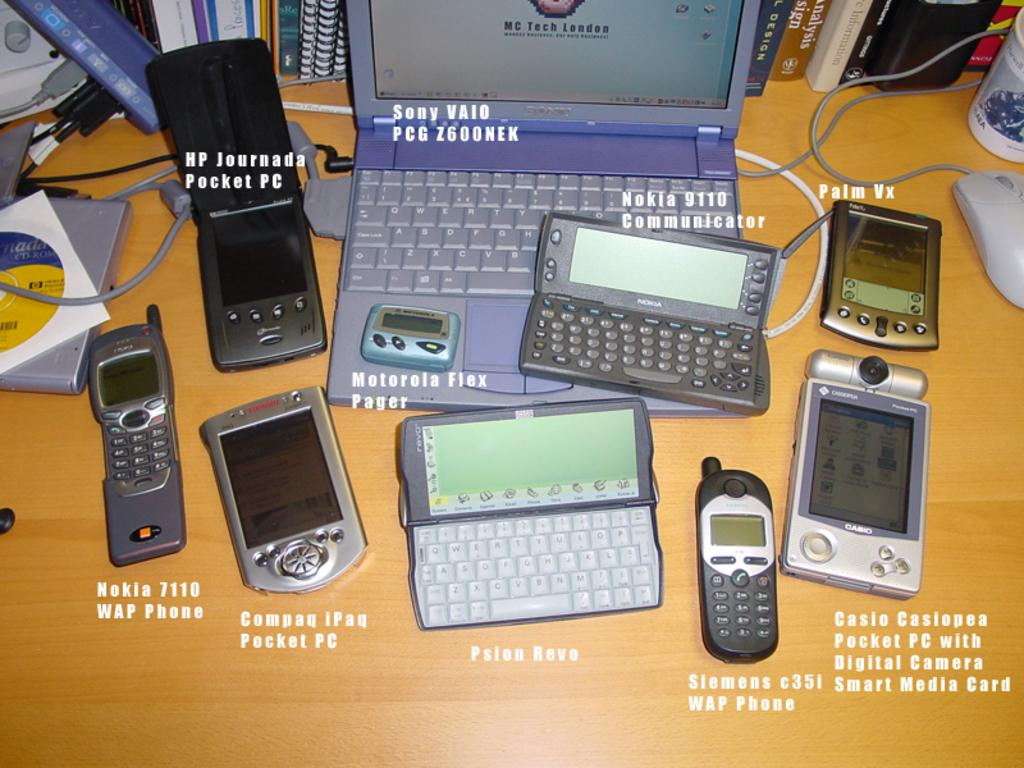<image>
Relay a brief, clear account of the picture shown. The company MC Tech London is displayed on the screen of a purple laptop. 